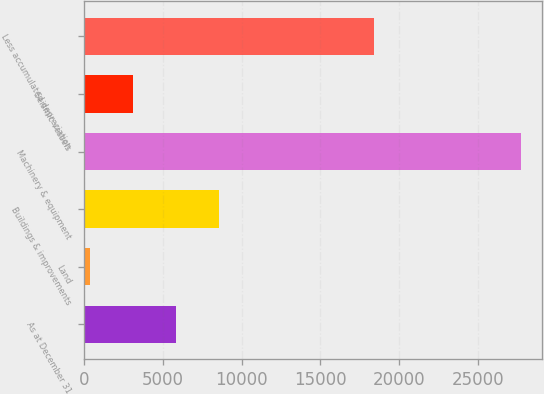Convert chart. <chart><loc_0><loc_0><loc_500><loc_500><bar_chart><fcel>As at December 31<fcel>Land<fcel>Buildings & improvements<fcel>Machinery & equipment<fcel>Seismic vessels<fcel>Less accumulated depreciation<nl><fcel>5830.8<fcel>366<fcel>8563.2<fcel>27690<fcel>3098.4<fcel>18388<nl></chart> 